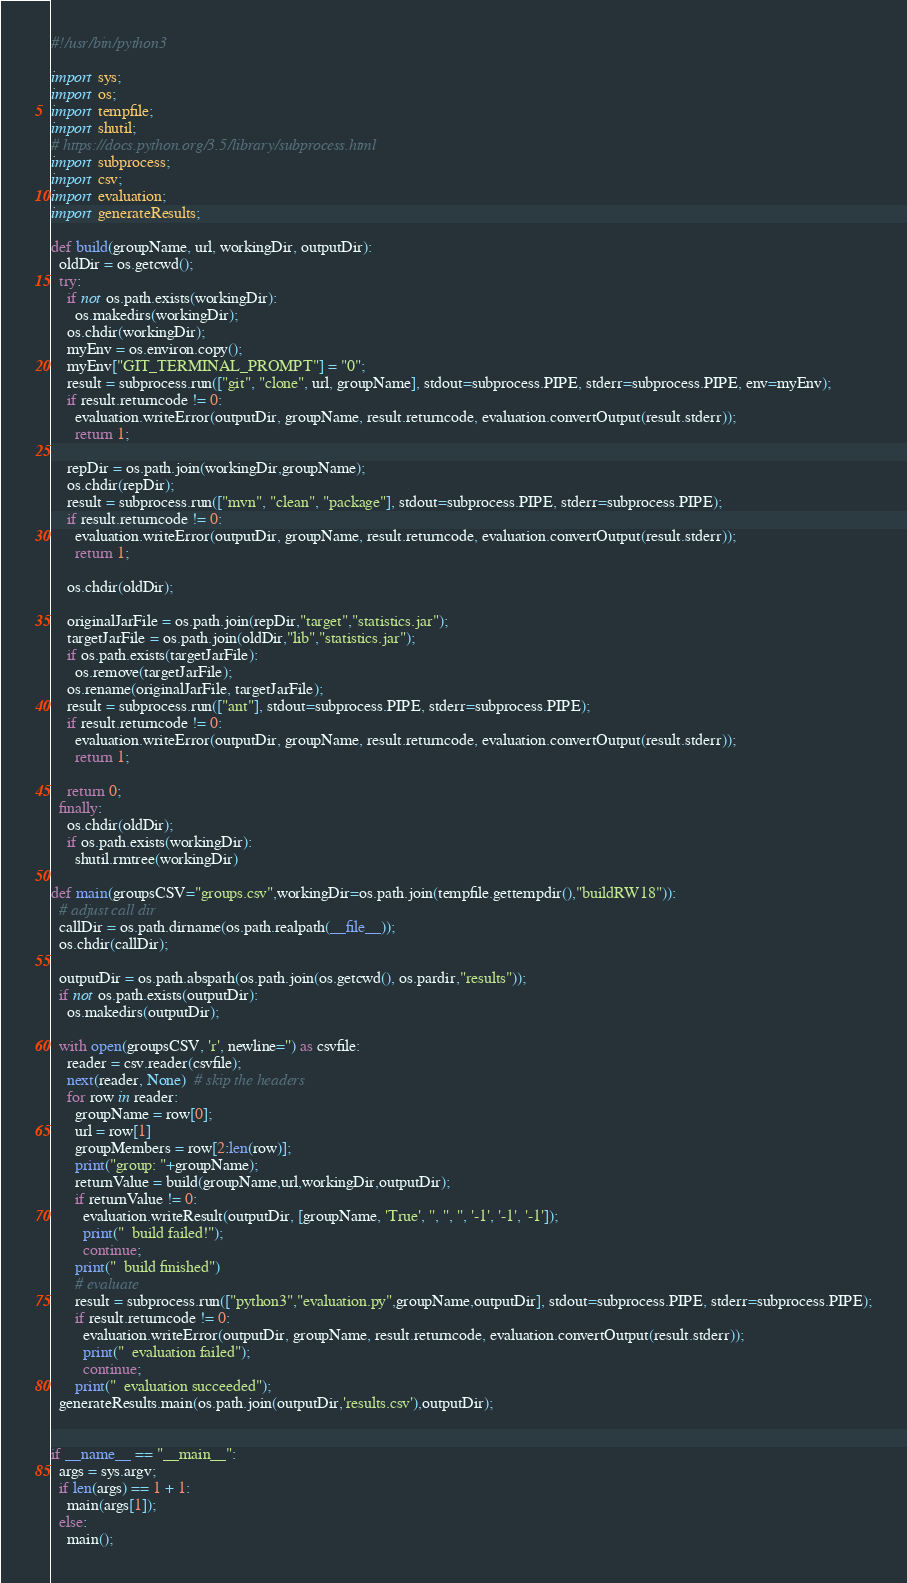<code> <loc_0><loc_0><loc_500><loc_500><_Python_>#!/usr/bin/python3

import sys;
import os;
import tempfile;
import shutil;
# https://docs.python.org/3.5/library/subprocess.html
import subprocess;
import csv;
import evaluation;
import generateResults;

def build(groupName, url, workingDir, outputDir):
  oldDir = os.getcwd();
  try:
    if not os.path.exists(workingDir):
      os.makedirs(workingDir);
    os.chdir(workingDir);
    myEnv = os.environ.copy();
    myEnv["GIT_TERMINAL_PROMPT"] = "0";
    result = subprocess.run(["git", "clone", url, groupName], stdout=subprocess.PIPE, stderr=subprocess.PIPE, env=myEnv);
    if result.returncode != 0:
      evaluation.writeError(outputDir, groupName, result.returncode, evaluation.convertOutput(result.stderr));
      return 1;
    
    repDir = os.path.join(workingDir,groupName);
    os.chdir(repDir);
    result = subprocess.run(["mvn", "clean", "package"], stdout=subprocess.PIPE, stderr=subprocess.PIPE);
    if result.returncode != 0:
      evaluation.writeError(outputDir, groupName, result.returncode, evaluation.convertOutput(result.stderr));
      return 1;
    
    os.chdir(oldDir);
    
    originalJarFile = os.path.join(repDir,"target","statistics.jar");
    targetJarFile = os.path.join(oldDir,"lib","statistics.jar");
    if os.path.exists(targetJarFile):
      os.remove(targetJarFile);
    os.rename(originalJarFile, targetJarFile);
    result = subprocess.run(["ant"], stdout=subprocess.PIPE, stderr=subprocess.PIPE);
    if result.returncode != 0:
      evaluation.writeError(outputDir, groupName, result.returncode, evaluation.convertOutput(result.stderr));
      return 1;
    
    return 0;
  finally:
    os.chdir(oldDir);
    if os.path.exists(workingDir):
      shutil.rmtree(workingDir)

def main(groupsCSV="groups.csv",workingDir=os.path.join(tempfile.gettempdir(),"buildRW18")):
  # adjust call dir
  callDir = os.path.dirname(os.path.realpath(__file__));
  os.chdir(callDir);
  
  outputDir = os.path.abspath(os.path.join(os.getcwd(), os.pardir,"results"));
  if not os.path.exists(outputDir):
    os.makedirs(outputDir);
  
  with open(groupsCSV, 'r', newline='') as csvfile:
    reader = csv.reader(csvfile);
    next(reader, None)  # skip the headers
    for row in reader:
      groupName = row[0];
      url = row[1]
      groupMembers = row[2:len(row)];
      print("group: "+groupName);
      returnValue = build(groupName,url,workingDir,outputDir);
      if returnValue != 0:
        evaluation.writeResult(outputDir, [groupName, 'True', '', '', '', '-1', '-1', '-1']);
        print("  build failed!");
        continue;
      print("  build finished")
      # evaluate
      result = subprocess.run(["python3","evaluation.py",groupName,outputDir], stdout=subprocess.PIPE, stderr=subprocess.PIPE);
      if result.returncode != 0:
        evaluation.writeError(outputDir, groupName, result.returncode, evaluation.convertOutput(result.stderr));
        print("  evaluation failed");
        continue;
      print("  evaluation succeeded");
  generateResults.main(os.path.join(outputDir,'results.csv'),outputDir);
  
  
if __name__ == "__main__":
  args = sys.argv;
  if len(args) == 1 + 1:
    main(args[1]);
  else:
    main();</code> 